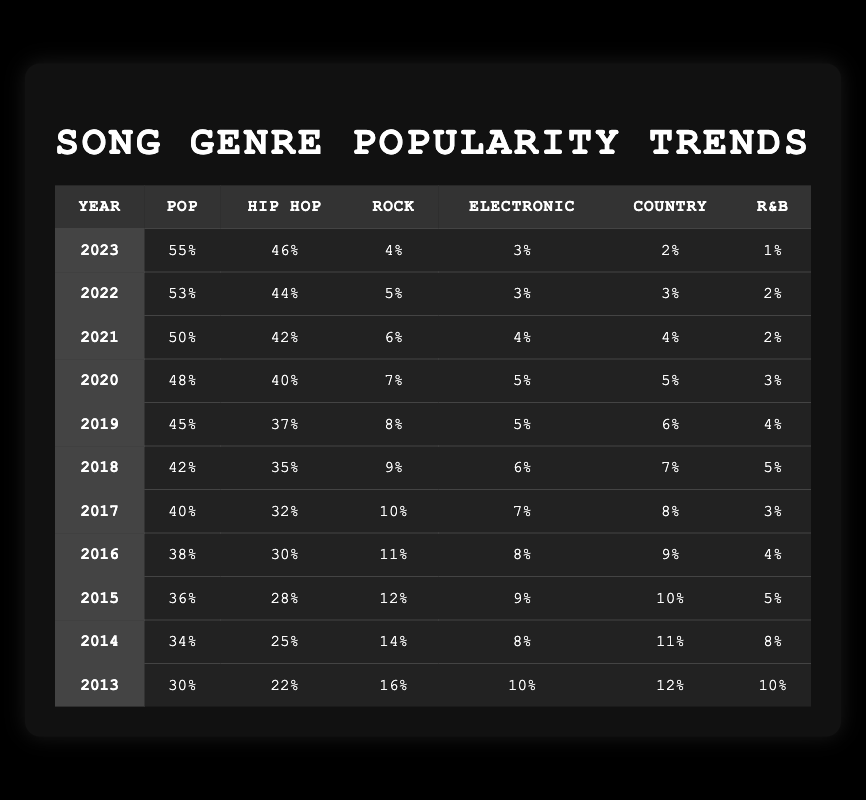What was the popularity percentage of Hip Hop in 2020? In 2020, the table shows that the popularity percentage of Hip Hop was 40%.
Answer: 40% What is the trend of Pop music popularity from 2013 to 2023? The popularity of Pop music increased from 30% in 2013 to 55% in 2023, showing a steadily increasing trend over the decade.
Answer: Increasing Which genre had the highest popularity in 2021? In 2021, Pop music had the highest popularity at 50%, compared to other genres listed in that year.
Answer: Pop What is the average popularity of Country music from 2013 to 2023? To find the average, sum the popularity of Country music from each year: (12 + 11 + 10 + 9 + 8 + 7 + 6 + 5 + 4 + 3 + 2) = 77. Divide by 11 years, which equals 7. Therefore, the average popularity is 7%.
Answer: 7% Did R&B music's popularity increase or decrease from 2013 to 2023? R&B music's popularity decreased from 10% in 2013 to 1% in 2023, indicating a decline in popularity over the decade.
Answer: Decrease Which genre had a popularity of exactly 5% in any year? The genre Rock had a popularity of exactly 5% in 2022, fulfilling the criteria of the question.
Answer: Yes, Rock in 2022 What was the change in popularity of Electronic music from 2013 to 2023? The popularity of Electronic music decreased from 10% in 2013 to 3% in 2023. The change is a drop of 7%.
Answer: Decrease by 7% Which year had the lowest popularity percentage for Rock music? The data shows that Rock music had the lowest popularity percentage in 2023 at 4%, which is lower than all previous years.
Answer: 2023 If we combine the popularity percentages of Electronic and Country music for 2019, what is the total? The popularity percentages for Electronic and Country in 2019 are 5% and 6%, respectively. Adding these gives: 5 + 6 = 11%.
Answer: 11% Was the popularity of Hip Hop music higher than Rock music in 2018? In 2018, Hip Hop music had a popularity of 35%, while Rock music was at 9%. Thus, Hip Hop's popularity was indeed higher than Rock's.
Answer: Yes What is the difference in popularity between Pop and R&B music in 2015? In 2015, Pop music had a popularity of 36% and R&B had 5%. The difference is 36 - 5 = 31%.
Answer: 31% 